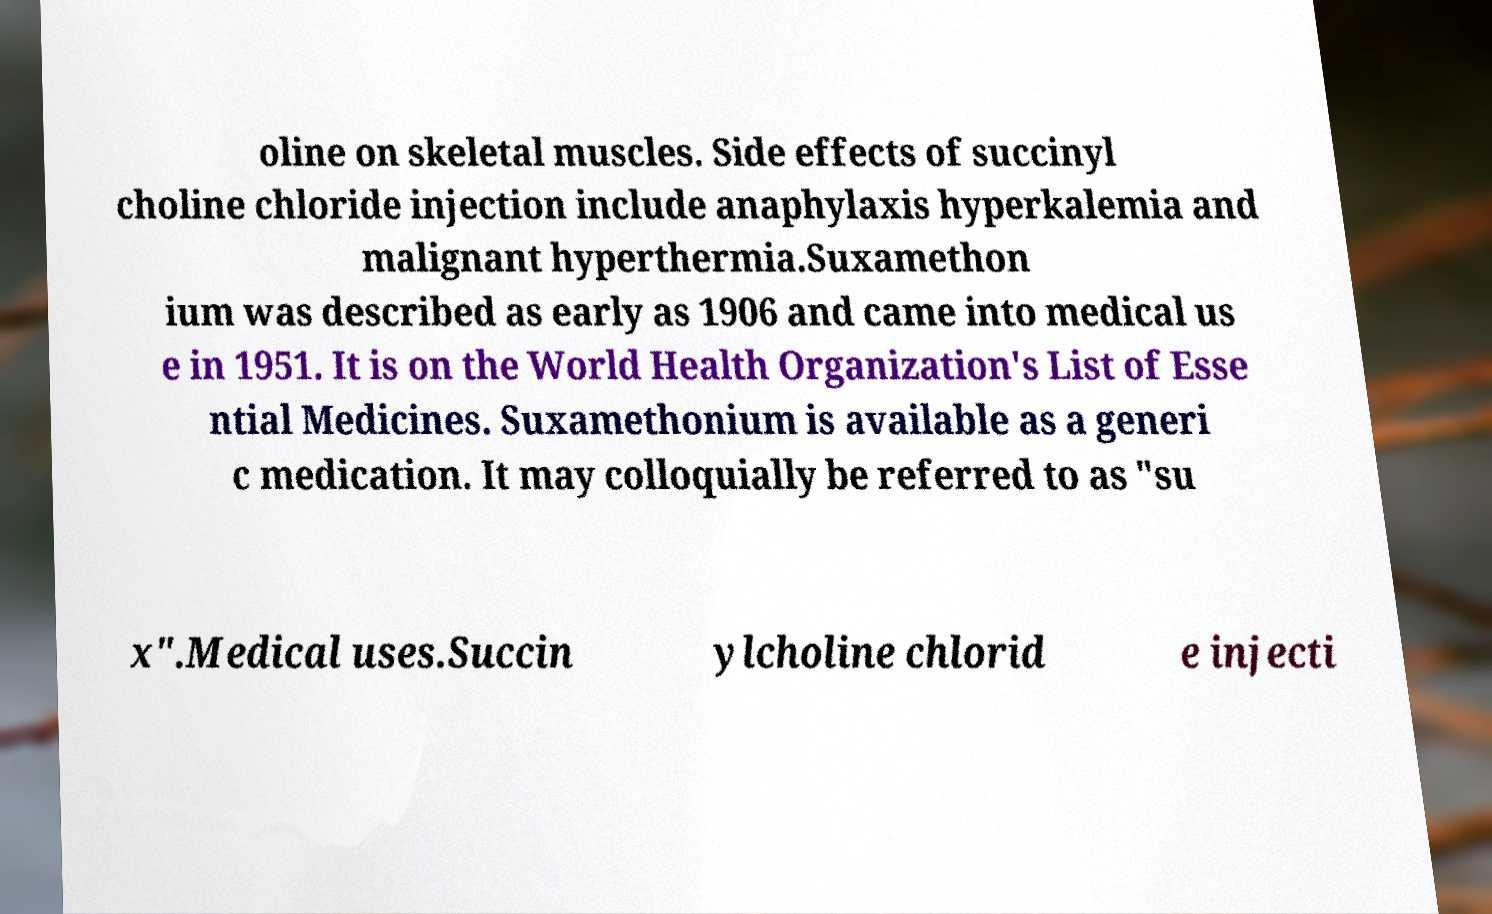Can you accurately transcribe the text from the provided image for me? oline on skeletal muscles. Side effects of succinyl choline chloride injection include anaphylaxis hyperkalemia and malignant hyperthermia.Suxamethon ium was described as early as 1906 and came into medical us e in 1951. It is on the World Health Organization's List of Esse ntial Medicines. Suxamethonium is available as a generi c medication. It may colloquially be referred to as "su x".Medical uses.Succin ylcholine chlorid e injecti 